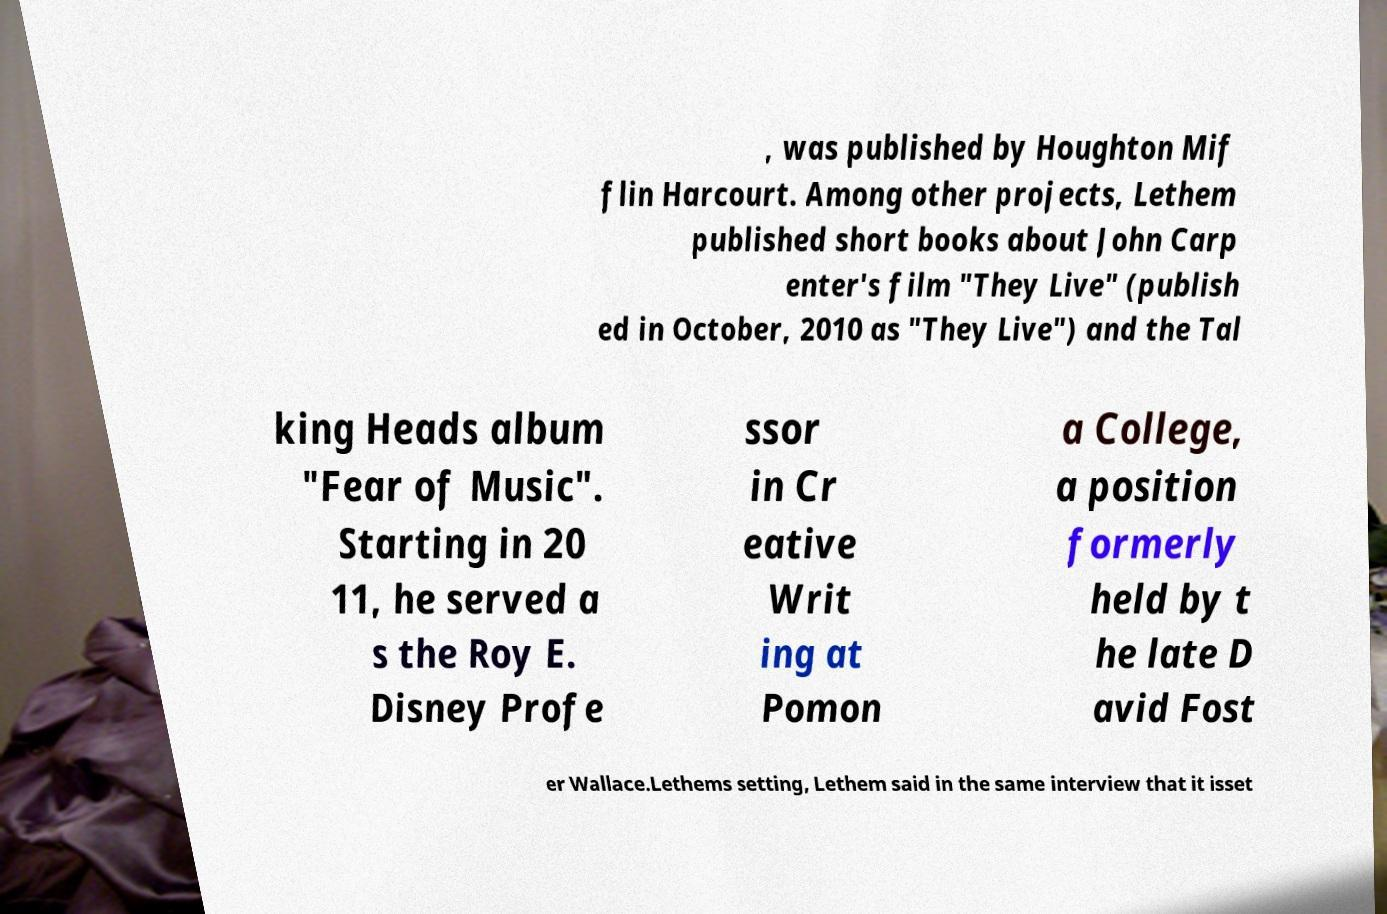Could you extract and type out the text from this image? , was published by Houghton Mif flin Harcourt. Among other projects, Lethem published short books about John Carp enter's film "They Live" (publish ed in October, 2010 as "They Live") and the Tal king Heads album "Fear of Music". Starting in 20 11, he served a s the Roy E. Disney Profe ssor in Cr eative Writ ing at Pomon a College, a position formerly held by t he late D avid Fost er Wallace.Lethems setting, Lethem said in the same interview that it isset 